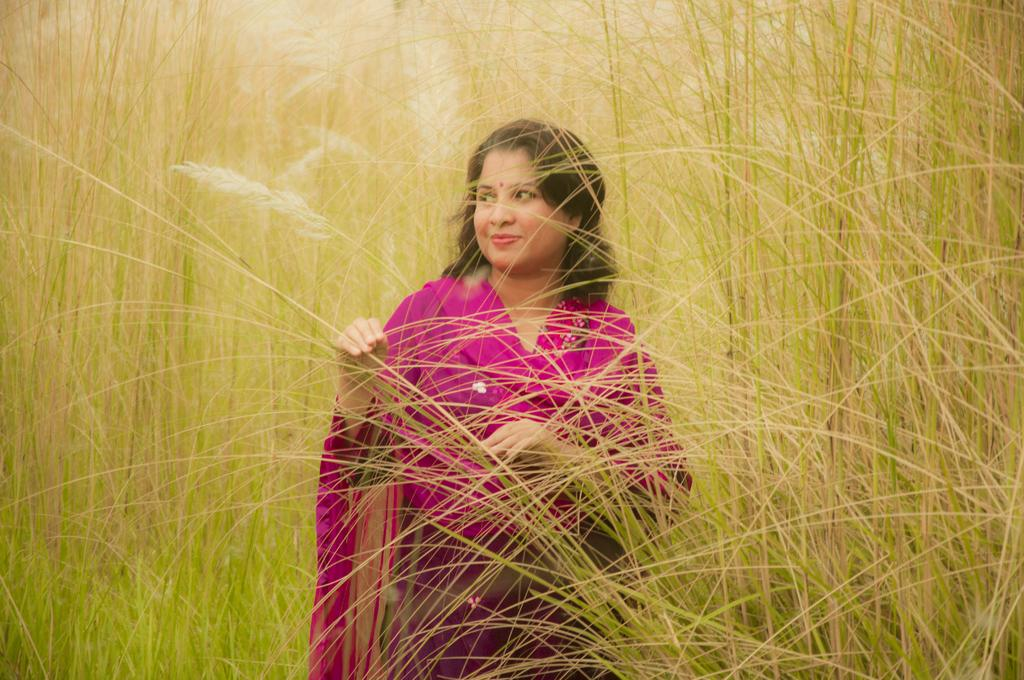Who is present in the image? There is a woman in the image. What is the woman's position in relation to the ground? The woman is standing on the ground. What type of natural elements can be seen in the image? There are plants visible in the image. What type of camera is the woman using to take pictures of her stomach in the image? There is no camera or mention of taking pictures in the image. 